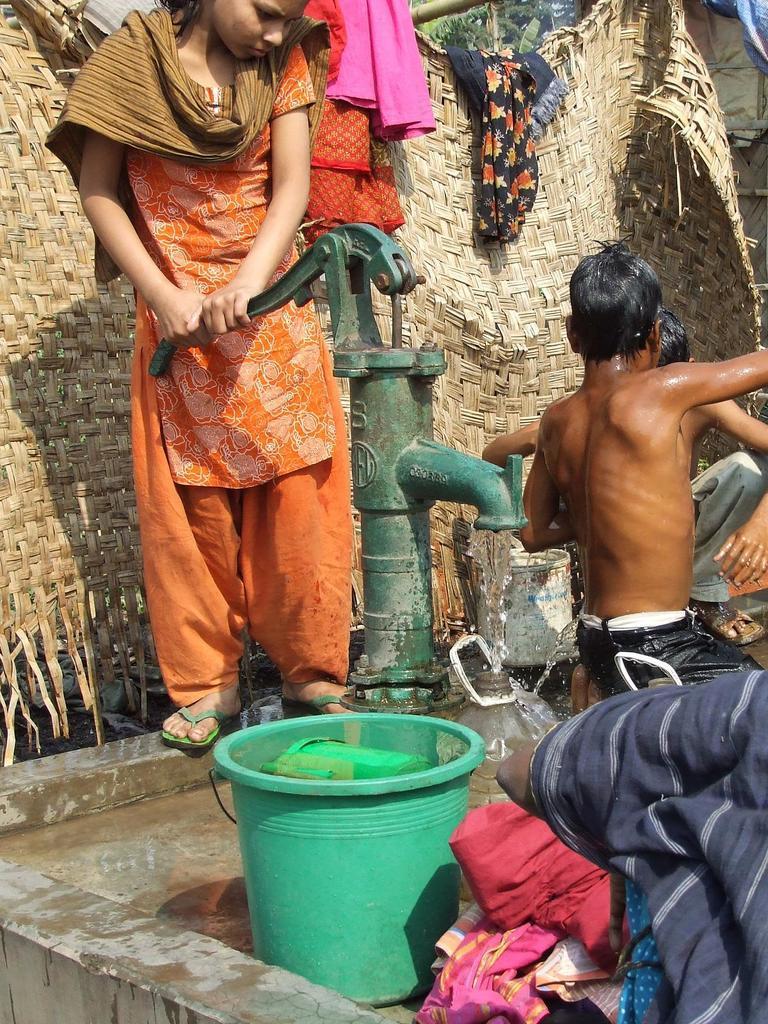How would you summarize this image in a sentence or two? In the image in the center, we can see a few people. And we can see one bucket, mug, water and clothes. In the background we can see clothes, trees and a few other objects. 